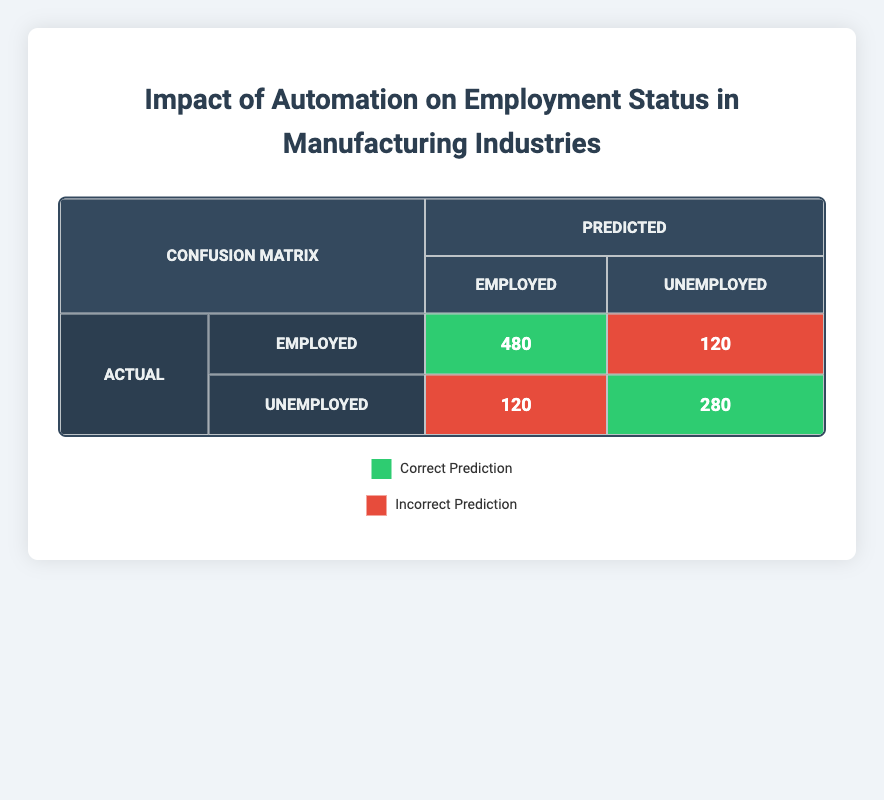What is the number of correctly predicted employed individuals? In the table, the number of individuals who were actually employed and predicted as employed is 480, shown in the cell where both actual and predicted are "Employed".
Answer: 480 What is the count of incorrectly predicted unemployed individuals? The table shows that there are 120 individuals who were actually unemployed but predicted as employed, indicated in the cell where actual is "Unemployed" and predicted is "Employed".
Answer: 120 What is the total number of individuals who were actually unemployed? To find the total number of individuals who were actually unemployed, sum the numbers in the "Unemployed" row: 100 (low automation) + 250 (high automation) = 350.
Answer: 350 How many total predictions were made for employed individuals? The predictions for employed individuals can be summed from the "Employed" column: 480 + 120 = 600.
Answer: 600 What is the difference in the number of unemployed individuals predicted between low automation and high automation? The table shows that for low automation, 120 were predicted unemployed, and for high automation, 280 were predicted unemployed. The difference is 280 - 120 = 160.
Answer: 160 Was the number of correctly predicted unemployed individuals more than those correctly predicted employed individuals? The number of correctly predicted unemployed individuals is 280, and the number of correctly predicted employed individuals is 480. Since 280 is less than 480, the statement is false.
Answer: No How does the total number of predicted individuals (both employed and unemployed) compare to the total actual individuals? For actual individuals: 500 employed + 100 unemployed + 150 employed + 250 unemployed = 1000; for predicted: 480 employed + 120 unemployed + 120 unemployed + 280 unemployed = 1000. The totals match, indicating no discrepancy.
Answer: They are equal What percentage of individuals were correctly predicted as employed? The number of correctly predicted employed is 480 out of a total of 600 predictions for employed (480 + 120). The percentage is (480/600) * 100 = 80%.
Answer: 80% What can be inferred about the impact of automation on unemployment from the predictions? From the table, the predictions show a higher number of individuals falsely predicted as unemployed (120) compared to those correctly predicted (280). This indicates that the model may have difficulties accurately predicting the effects of high automation on employment status.
Answer: The model may mispredict unemployment rates 